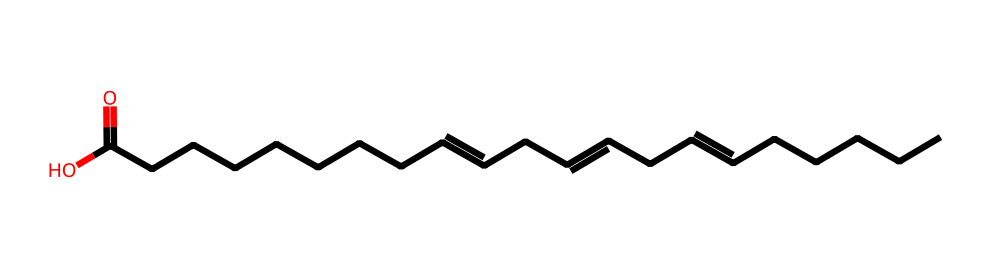What is the total number of carbon atoms in this omega-3 fatty acid? By analyzing the SMILES representation, I count the 'C' symbols that represent carbon atoms. The total count comes to 18.
Answer: 18 How many double bonds are present in this molecule? In the SMILES representation, I observe two '=' symbols that indicate double bonds between carbon atoms. Therefore, there are two double bonds in this structure.
Answer: 2 What functional group is represented by the 'C(=O)O' at the end of this chemical structure? The 'C(=O)O' indicates a carboxylic acid functional group, which is characterized by a carbon atom double-bonded to an oxygen atom and also bonded to a hydroxyl group (OH).
Answer: carboxylic acid Is this fatty acid saturated or unsaturated? The presence of double bonds ('=') in the structure indicates that this fatty acid is unsaturated since saturated fatty acids do not have double bonds.
Answer: unsaturated Which lipid category does this molecule fall into? Since the structure shows a long hydrocarbon chain with a carboxylic acid group, it classifies this molecule as a fatty acid, which is a common category of lipids.
Answer: fatty acid What does the presence of omega-3 indicate about the position of the first double bond? The term omega-3 indicates that the first double bond is located at the third carbon from the terminal methyl group (the omega carbon) in the fatty acid chain.
Answer: third carbon 